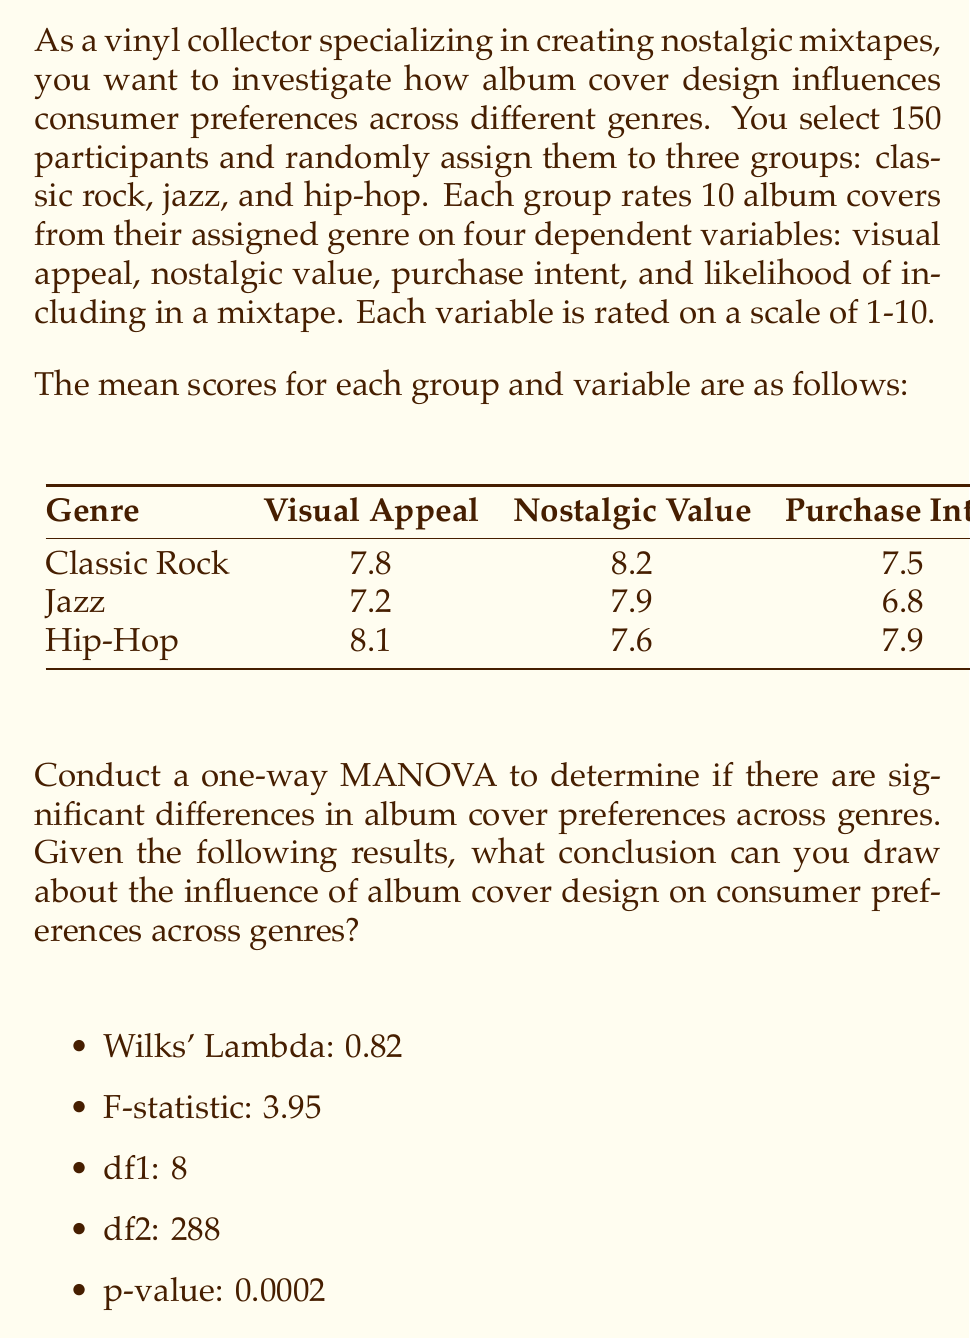Show me your answer to this math problem. To interpret the MANOVA results and draw a conclusion about the influence of album cover design on consumer preferences across genres, we need to follow these steps:

1. Understand the null hypothesis:
   $H_0$: There are no significant differences in album cover preferences across genres.
   $H_a$: There are significant differences in album cover preferences across genres.

2. Interpret Wilks' Lambda:
   Wilks' Lambda ranges from 0 to 1, where values closer to 0 indicate greater differences between groups. In this case, Wilks' Lambda = 0.82, suggesting some differences between groups, but not extremely large.

3. Examine the F-statistic and degrees of freedom:
   F-statistic = 3.95
   df1 = 8 (between-groups degrees of freedom)
   df2 = 288 (within-groups degrees of freedom)

4. Evaluate the p-value:
   p-value = 0.0002

5. Compare the p-value to the significance level:
   Typically, we use α = 0.05 as the significance level. Since p-value (0.0002) < α (0.05), we reject the null hypothesis.

6. Draw a conclusion:
   Rejecting the null hypothesis means that there are statistically significant differences in album cover preferences across genres. This suggests that album cover design does influence consumer preferences, and these preferences vary depending on the genre.

7. Consider practical significance:
   While the differences are statistically significant, the Wilks' Lambda of 0.82 suggests that the effect may not be extremely large. This means that while genre does influence preferences, other factors may also play important roles.

8. Relate to the vinyl collector persona:
   As a vinyl collector creating nostalgic mixtapes, this information is valuable for understanding how album cover design might influence the selection of tracks for different genre-based mixtapes and potentially impact the overall nostalgic experience for listeners.
Answer: Album cover design significantly influences consumer preferences across genres (p < 0.05), with moderate effect size (Wilks' Lambda = 0.82). 